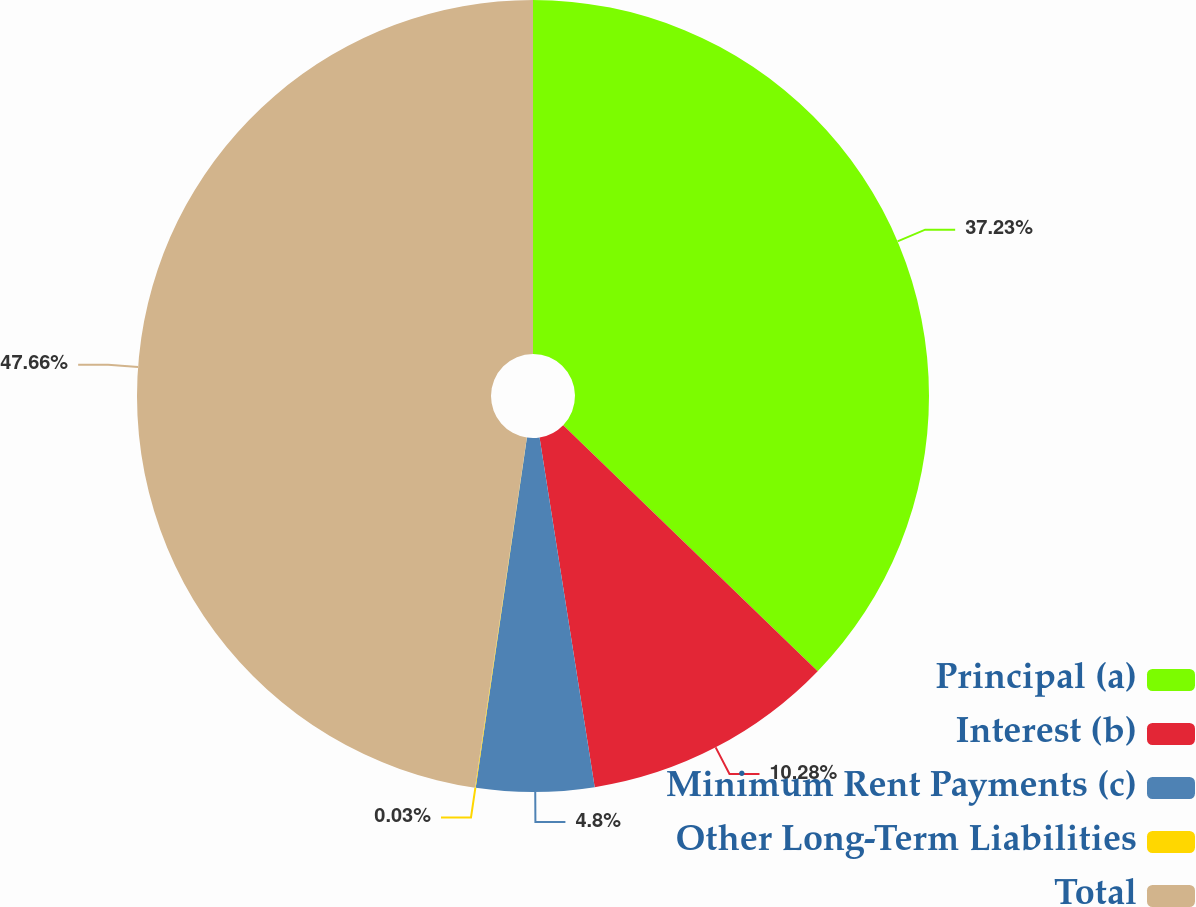<chart> <loc_0><loc_0><loc_500><loc_500><pie_chart><fcel>Principal (a)<fcel>Interest (b)<fcel>Minimum Rent Payments (c)<fcel>Other Long-Term Liabilities<fcel>Total<nl><fcel>37.23%<fcel>10.28%<fcel>4.8%<fcel>0.03%<fcel>47.66%<nl></chart> 